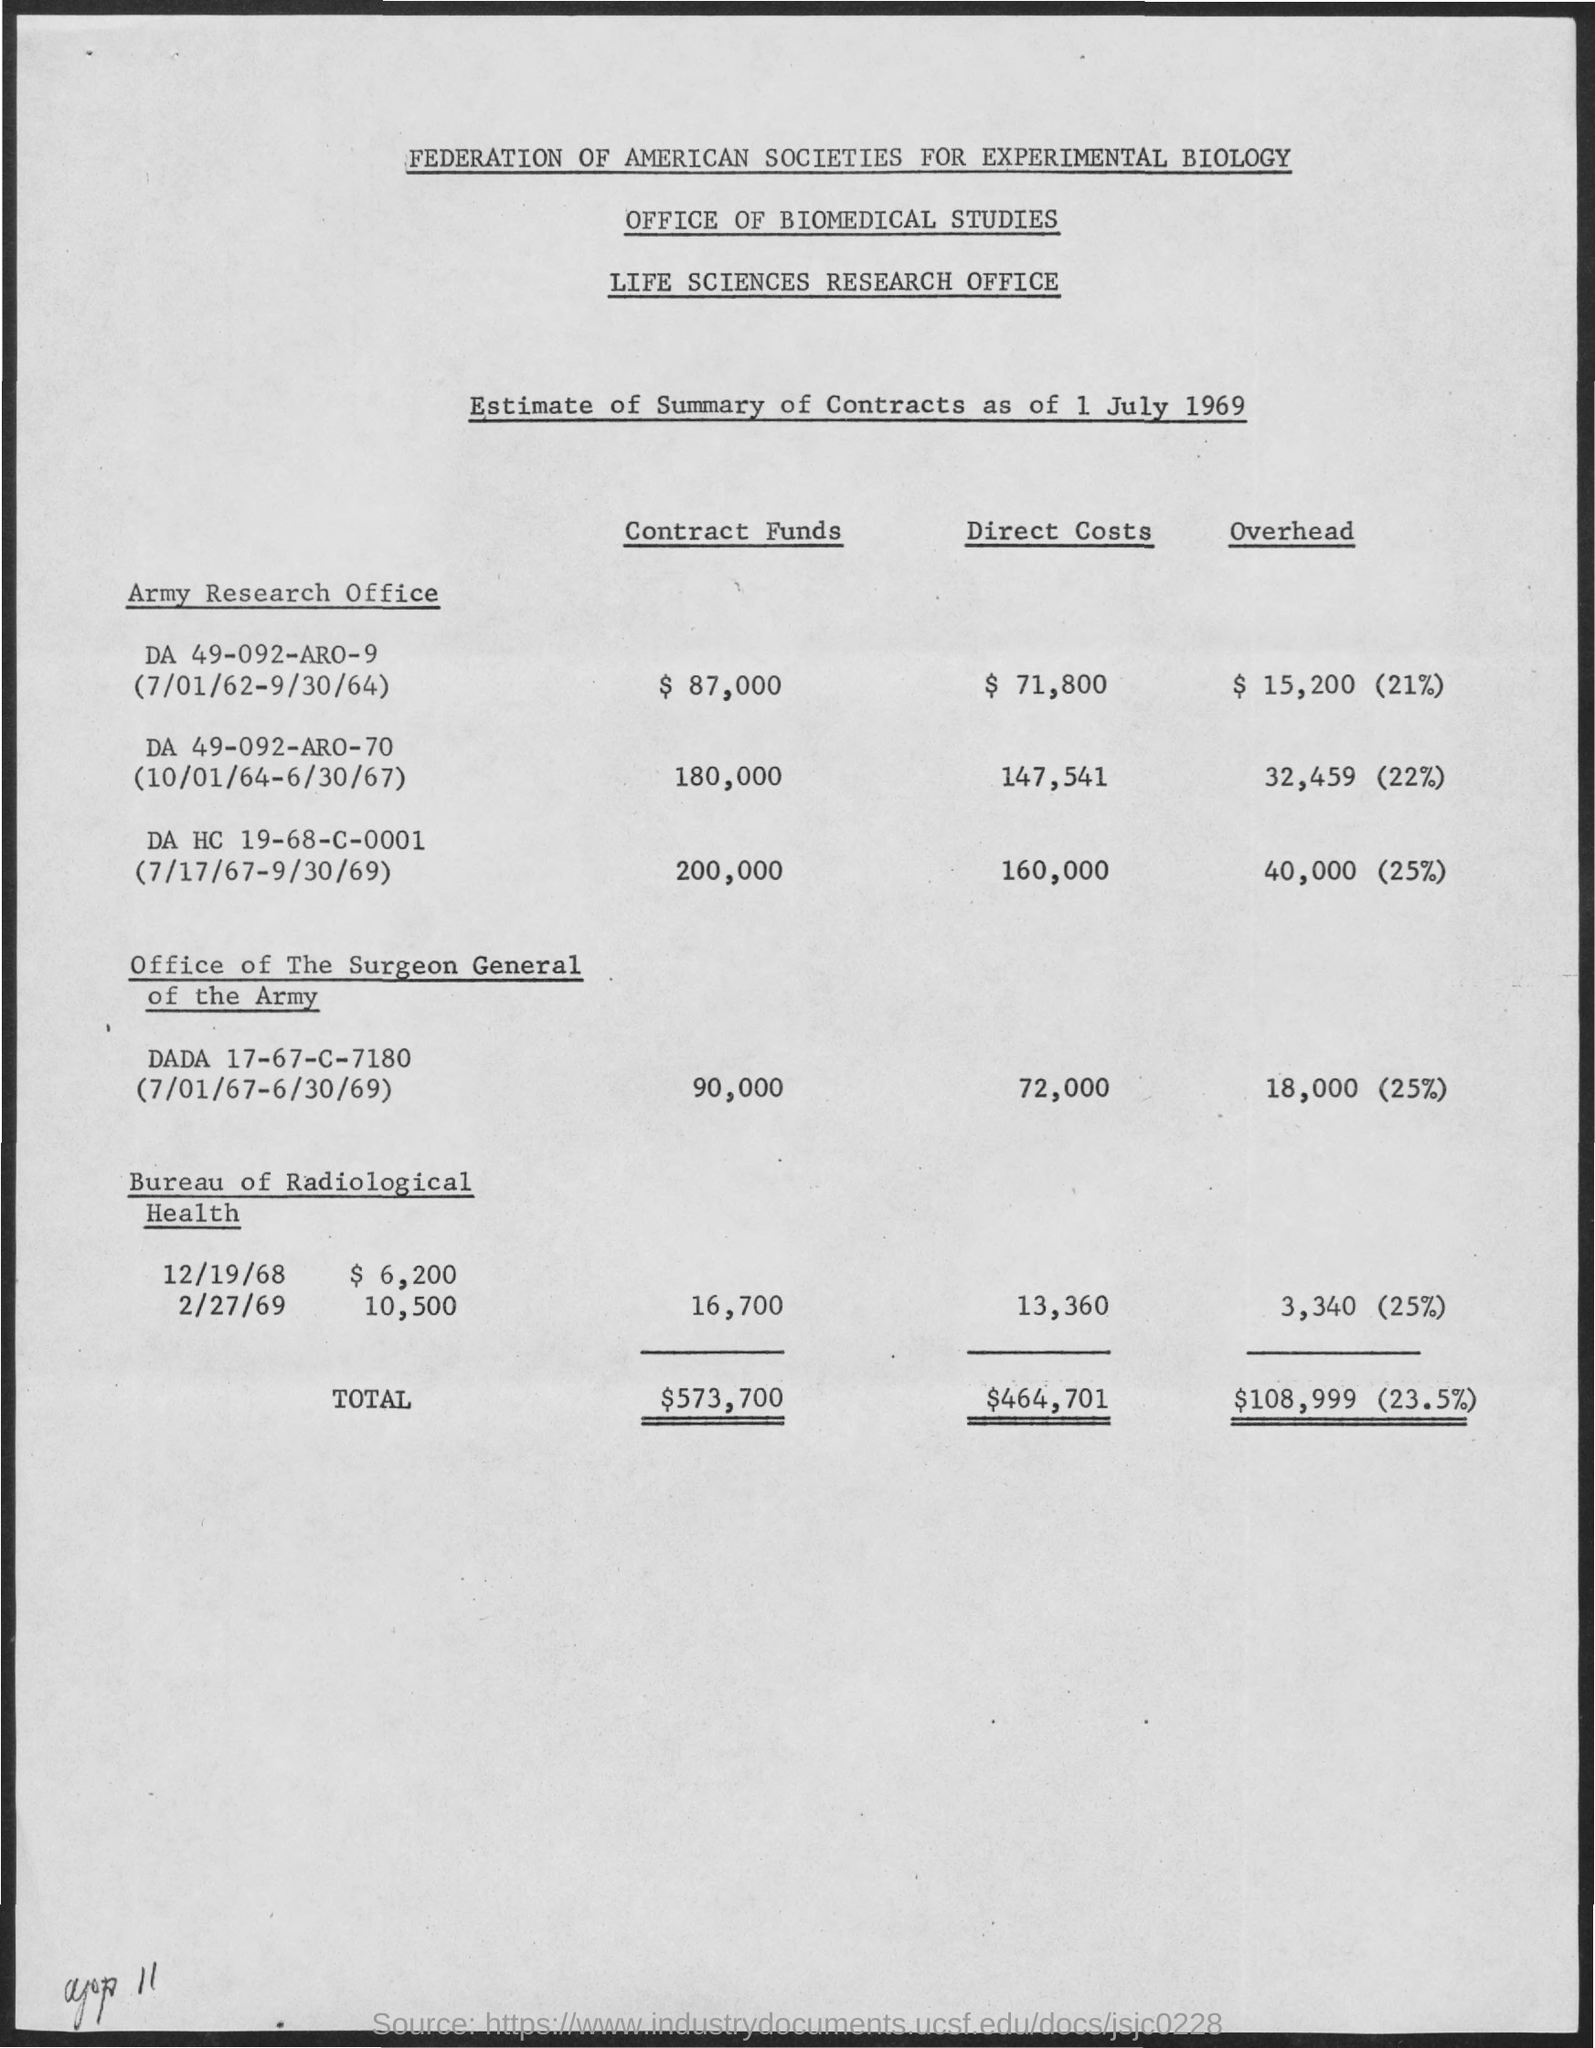Outline some significant characteristics in this image. The direct costs for the Army research office DA 49-092-ARO-70 from October 1st, 1964 to June 30th, 1967 were $147,541. The Army research office's overhead expenses for the period of July 1, 1962 to September 30, 1964 were $15,200, which represented 21% of the total funds allocated. The Contract funds for Army research office DA 49-092-ARO-70 were $180,000, from October 1, 1964 to June 30, 1967. The total overhead amount is 108,999, representing 23.5% of the expenses. The overhead costs for Army Research Office DA 49-092-ARO-70 between October 1, 1964 and June 30, 1967 were $32,459. 